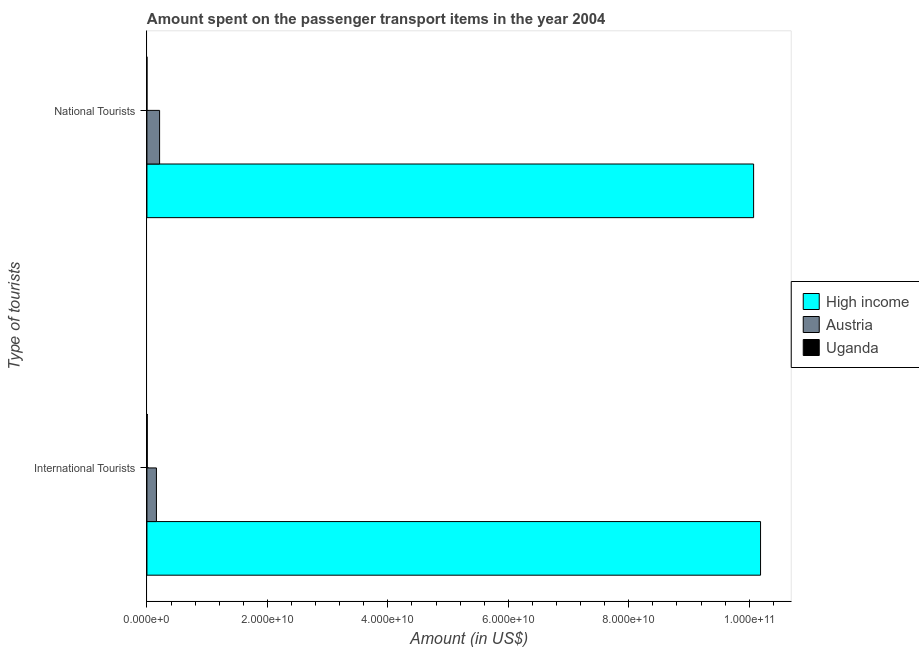How many different coloured bars are there?
Your response must be concise. 3. Are the number of bars on each tick of the Y-axis equal?
Make the answer very short. Yes. What is the label of the 1st group of bars from the top?
Offer a terse response. National Tourists. What is the amount spent on transport items of international tourists in High income?
Your answer should be very brief. 1.02e+11. Across all countries, what is the maximum amount spent on transport items of national tourists?
Your answer should be compact. 1.01e+11. Across all countries, what is the minimum amount spent on transport items of national tourists?
Provide a succinct answer. 1.00e+06. In which country was the amount spent on transport items of international tourists maximum?
Offer a terse response. High income. In which country was the amount spent on transport items of international tourists minimum?
Your answer should be compact. Uganda. What is the total amount spent on transport items of national tourists in the graph?
Offer a very short reply. 1.03e+11. What is the difference between the amount spent on transport items of national tourists in Austria and that in High income?
Provide a succinct answer. -9.86e+1. What is the difference between the amount spent on transport items of national tourists in Austria and the amount spent on transport items of international tourists in Uganda?
Offer a very short reply. 2.05e+09. What is the average amount spent on transport items of international tourists per country?
Your response must be concise. 3.45e+1. What is the difference between the amount spent on transport items of national tourists and amount spent on transport items of international tourists in Austria?
Give a very brief answer. 5.26e+08. What is the ratio of the amount spent on transport items of international tourists in Austria to that in High income?
Offer a terse response. 0.02. Is the amount spent on transport items of national tourists in Uganda less than that in Austria?
Provide a short and direct response. Yes. What does the 3rd bar from the top in International Tourists represents?
Provide a short and direct response. High income. How many bars are there?
Your response must be concise. 6. Are all the bars in the graph horizontal?
Your answer should be compact. Yes. How many countries are there in the graph?
Your answer should be very brief. 3. Where does the legend appear in the graph?
Offer a very short reply. Center right. What is the title of the graph?
Provide a short and direct response. Amount spent on the passenger transport items in the year 2004. What is the label or title of the Y-axis?
Offer a terse response. Type of tourists. What is the Amount (in US$) of High income in International Tourists?
Provide a short and direct response. 1.02e+11. What is the Amount (in US$) of Austria in International Tourists?
Ensure brevity in your answer.  1.58e+09. What is the Amount (in US$) of High income in National Tourists?
Your response must be concise. 1.01e+11. What is the Amount (in US$) in Austria in National Tourists?
Your response must be concise. 2.10e+09. What is the Amount (in US$) of Uganda in National Tourists?
Your answer should be very brief. 1.00e+06. Across all Type of tourists, what is the maximum Amount (in US$) of High income?
Provide a succinct answer. 1.02e+11. Across all Type of tourists, what is the maximum Amount (in US$) of Austria?
Give a very brief answer. 2.10e+09. Across all Type of tourists, what is the maximum Amount (in US$) in Uganda?
Your answer should be very brief. 5.00e+07. Across all Type of tourists, what is the minimum Amount (in US$) in High income?
Provide a short and direct response. 1.01e+11. Across all Type of tourists, what is the minimum Amount (in US$) of Austria?
Keep it short and to the point. 1.58e+09. What is the total Amount (in US$) of High income in the graph?
Offer a terse response. 2.03e+11. What is the total Amount (in US$) in Austria in the graph?
Your answer should be compact. 3.68e+09. What is the total Amount (in US$) in Uganda in the graph?
Keep it short and to the point. 5.10e+07. What is the difference between the Amount (in US$) of High income in International Tourists and that in National Tourists?
Your answer should be compact. 1.15e+09. What is the difference between the Amount (in US$) in Austria in International Tourists and that in National Tourists?
Your answer should be very brief. -5.26e+08. What is the difference between the Amount (in US$) of Uganda in International Tourists and that in National Tourists?
Your response must be concise. 4.90e+07. What is the difference between the Amount (in US$) of High income in International Tourists and the Amount (in US$) of Austria in National Tourists?
Offer a terse response. 9.98e+1. What is the difference between the Amount (in US$) in High income in International Tourists and the Amount (in US$) in Uganda in National Tourists?
Offer a very short reply. 1.02e+11. What is the difference between the Amount (in US$) in Austria in International Tourists and the Amount (in US$) in Uganda in National Tourists?
Offer a very short reply. 1.57e+09. What is the average Amount (in US$) in High income per Type of tourists?
Your response must be concise. 1.01e+11. What is the average Amount (in US$) in Austria per Type of tourists?
Give a very brief answer. 1.84e+09. What is the average Amount (in US$) of Uganda per Type of tourists?
Your answer should be compact. 2.55e+07. What is the difference between the Amount (in US$) in High income and Amount (in US$) in Austria in International Tourists?
Keep it short and to the point. 1.00e+11. What is the difference between the Amount (in US$) of High income and Amount (in US$) of Uganda in International Tourists?
Provide a succinct answer. 1.02e+11. What is the difference between the Amount (in US$) in Austria and Amount (in US$) in Uganda in International Tourists?
Offer a terse response. 1.52e+09. What is the difference between the Amount (in US$) of High income and Amount (in US$) of Austria in National Tourists?
Make the answer very short. 9.86e+1. What is the difference between the Amount (in US$) in High income and Amount (in US$) in Uganda in National Tourists?
Provide a short and direct response. 1.01e+11. What is the difference between the Amount (in US$) of Austria and Amount (in US$) of Uganda in National Tourists?
Provide a short and direct response. 2.10e+09. What is the ratio of the Amount (in US$) of High income in International Tourists to that in National Tourists?
Provide a short and direct response. 1.01. What is the ratio of the Amount (in US$) of Austria in International Tourists to that in National Tourists?
Give a very brief answer. 0.75. What is the ratio of the Amount (in US$) in Uganda in International Tourists to that in National Tourists?
Make the answer very short. 50. What is the difference between the highest and the second highest Amount (in US$) of High income?
Offer a terse response. 1.15e+09. What is the difference between the highest and the second highest Amount (in US$) in Austria?
Make the answer very short. 5.26e+08. What is the difference between the highest and the second highest Amount (in US$) of Uganda?
Your answer should be very brief. 4.90e+07. What is the difference between the highest and the lowest Amount (in US$) in High income?
Keep it short and to the point. 1.15e+09. What is the difference between the highest and the lowest Amount (in US$) of Austria?
Your answer should be compact. 5.26e+08. What is the difference between the highest and the lowest Amount (in US$) of Uganda?
Give a very brief answer. 4.90e+07. 